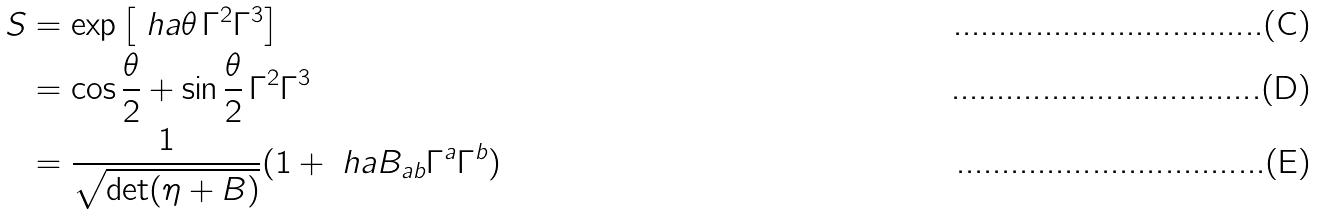Convert formula to latex. <formula><loc_0><loc_0><loc_500><loc_500>S & = \exp \left [ \ h a \theta \, \Gamma ^ { 2 } \Gamma ^ { 3 } \right ] \\ & = \cos \frac { \theta } { 2 } + \sin \frac { \theta } { 2 } \, \Gamma ^ { 2 } \Gamma ^ { 3 } \\ & = \frac { 1 } { \sqrt { \det ( \eta + B ) } } ( 1 + \ h a B _ { a b } \Gamma ^ { a } \Gamma ^ { b } )</formula> 